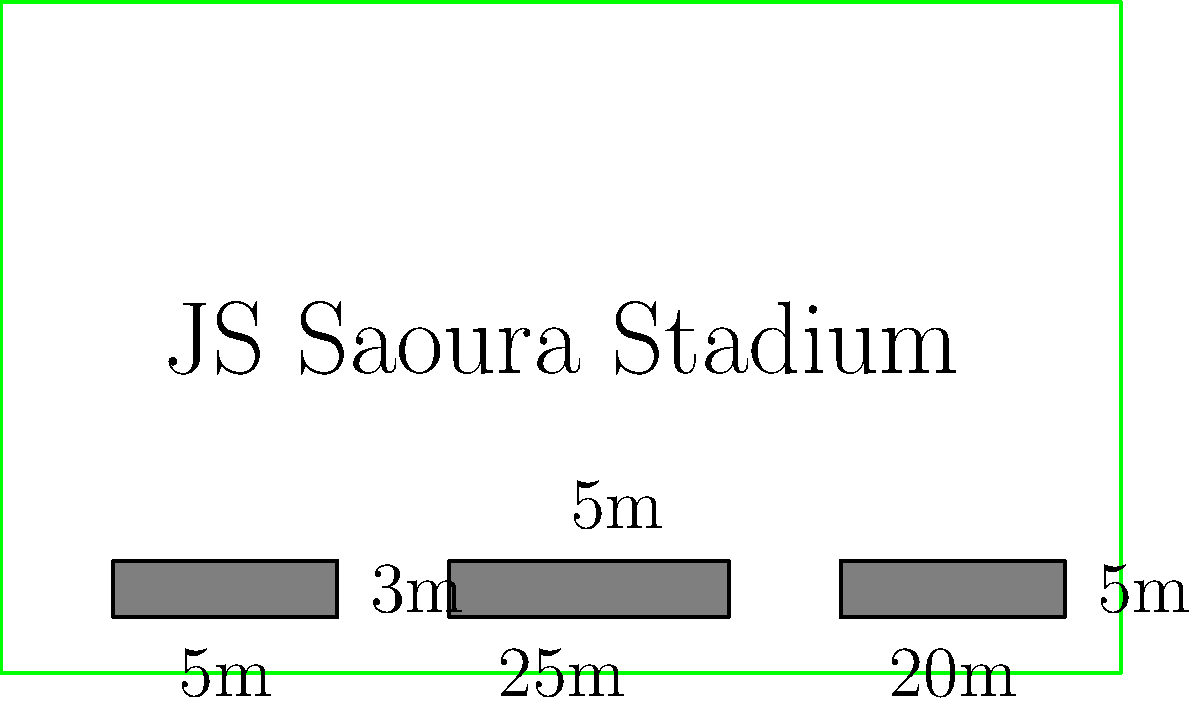At the JS Saoura stadium, there are three rectangular player benches along the sideline. The dimensions of these benches are as follows:
- Bench 1: 5m x 3m
- Bench 2: 25m x 5m
- Bench 3: 20m x 5m
What is the total area occupied by all three benches combined? To find the total area occupied by all three benches, we need to:
1. Calculate the area of each bench
2. Sum up the areas of all benches

Step 1: Calculate the area of each bench
- Area of Bench 1: $A_1 = 5m \times 3m = 15m^2$
- Area of Bench 2: $A_2 = 25m \times 5m = 125m^2$
- Area of Bench 3: $A_3 = 20m \times 5m = 100m^2$

Step 2: Sum up the areas of all benches
Total Area = $A_1 + A_2 + A_3$
Total Area = $15m^2 + 125m^2 + 100m^2 = 240m^2$

Therefore, the total area occupied by all three benches is $240m^2$.
Answer: $240m^2$ 